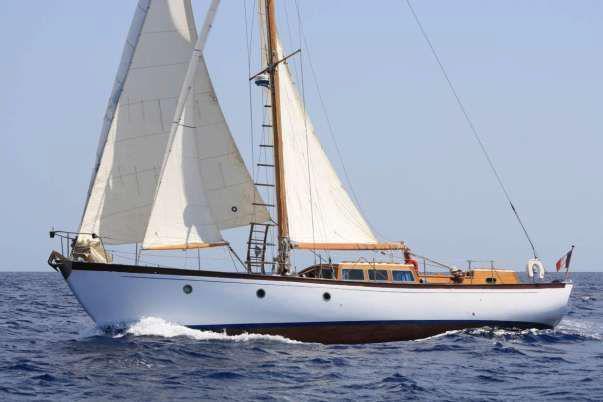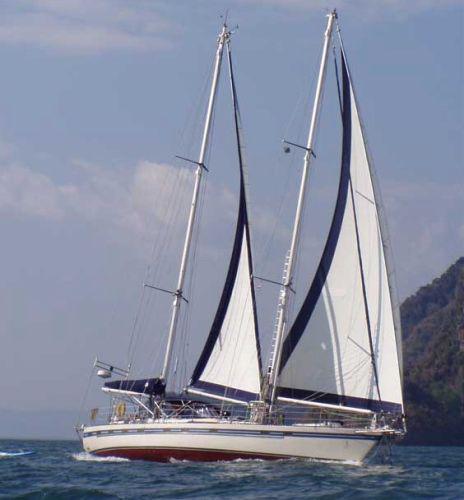The first image is the image on the left, the second image is the image on the right. Examine the images to the left and right. Is the description "The boat in the image on the right is lighter in color than the boat in the image on the left." accurate? Answer yes or no. No. The first image is the image on the left, the second image is the image on the right. Evaluate the accuracy of this statement regarding the images: "One sailboat has a dark exterior and no more than four sails.". Is it true? Answer yes or no. No. 